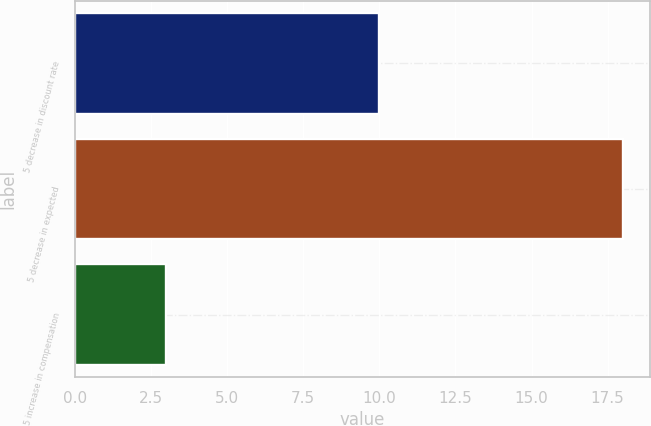<chart> <loc_0><loc_0><loc_500><loc_500><bar_chart><fcel>5 decrease in discount rate<fcel>5 decrease in expected<fcel>5 increase in compensation<nl><fcel>10<fcel>18<fcel>3<nl></chart> 